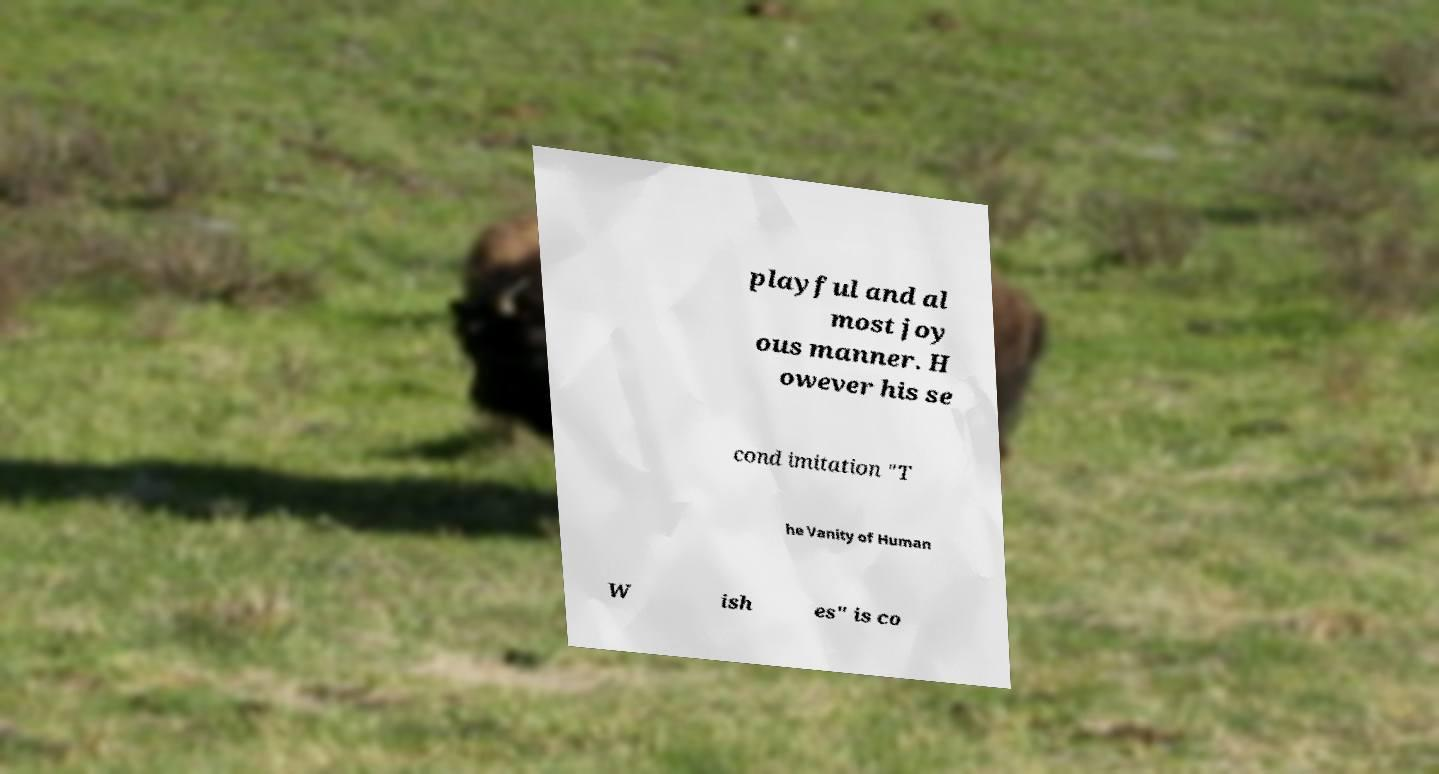Please read and relay the text visible in this image. What does it say? playful and al most joy ous manner. H owever his se cond imitation "T he Vanity of Human W ish es" is co 